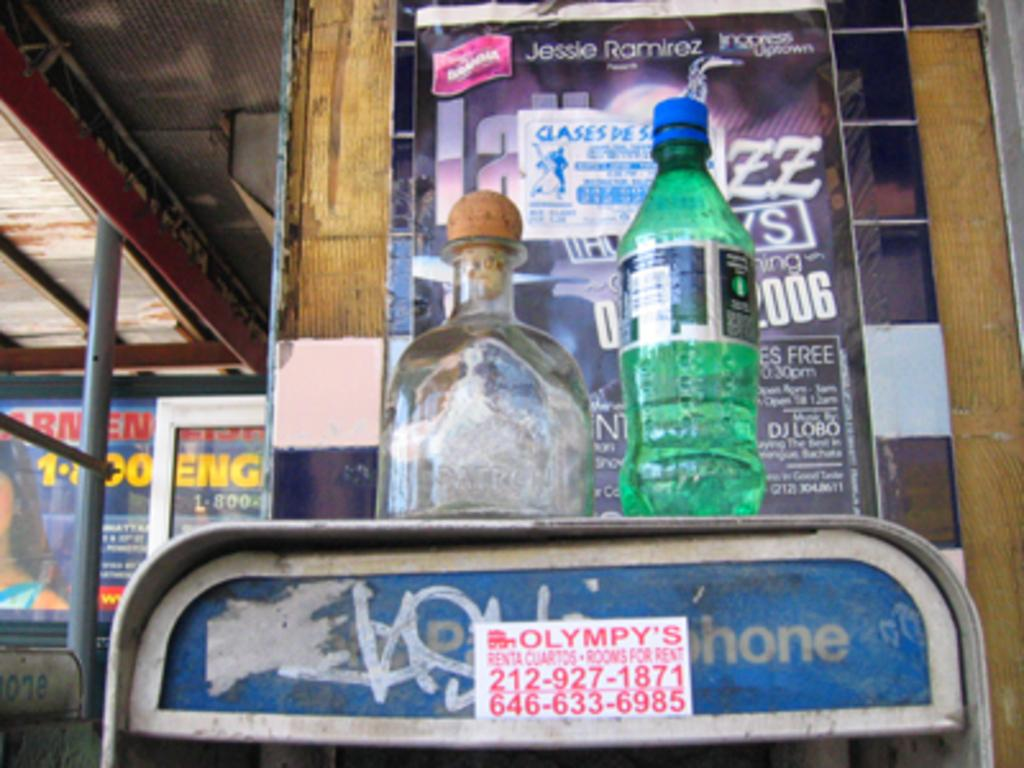<image>
Offer a succinct explanation of the picture presented. An empty patron bottle, and a Sprite bottle sit on top of a pay phone booth. 